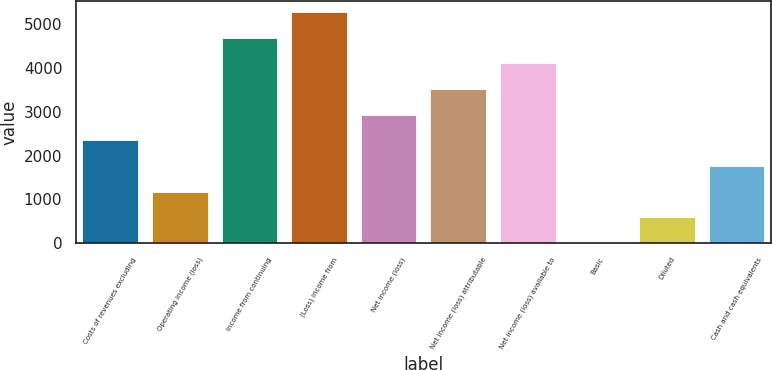<chart> <loc_0><loc_0><loc_500><loc_500><bar_chart><fcel>Costs of revenues excluding<fcel>Operating income (loss)<fcel>Income from continuing<fcel>(Loss) income from<fcel>Net income (loss)<fcel>Net income (loss) attributable<fcel>Net income (loss) available to<fcel>Basic<fcel>Diluted<fcel>Cash and cash equivalents<nl><fcel>2346.59<fcel>1173.45<fcel>4692.87<fcel>5279.44<fcel>2933.16<fcel>3519.73<fcel>4106.3<fcel>0.31<fcel>586.88<fcel>1760.02<nl></chart> 